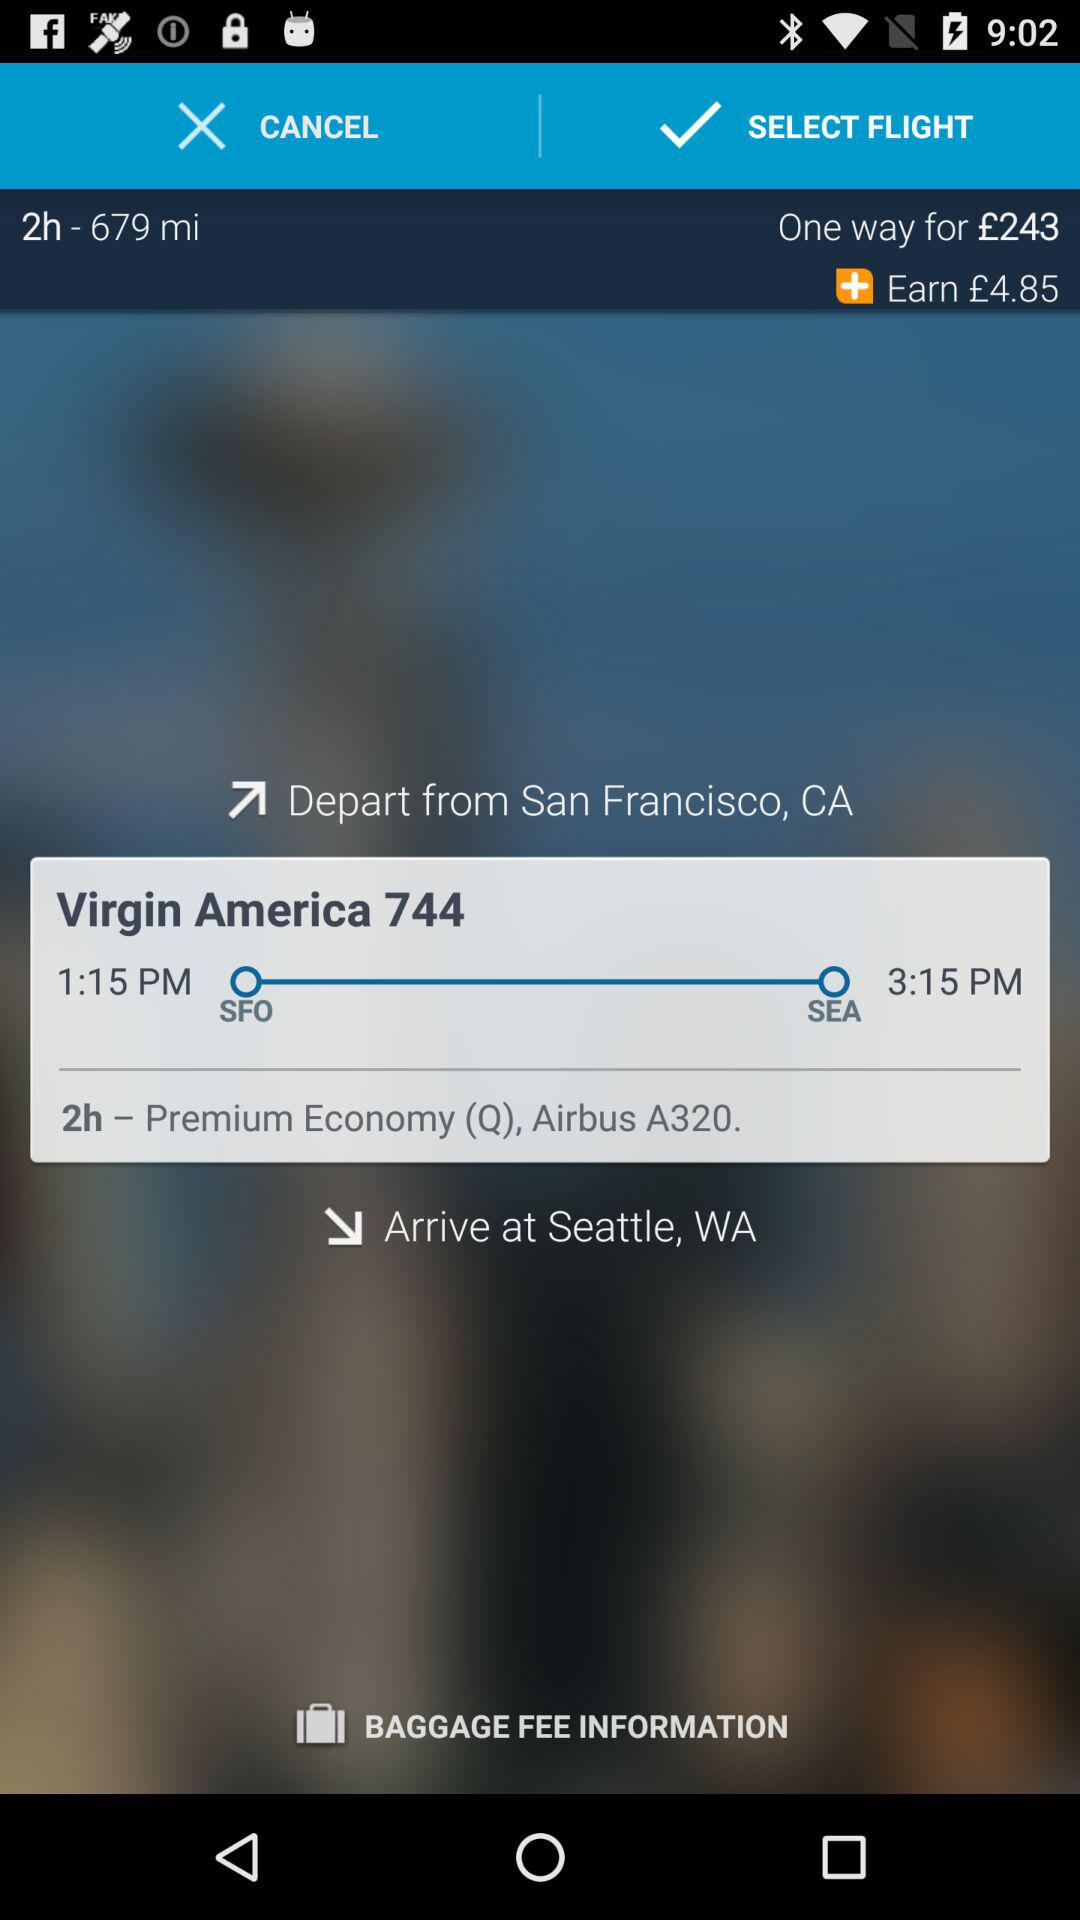What is the name of the airline? The name of the airline is "Virgin America". 